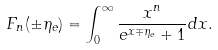Convert formula to latex. <formula><loc_0><loc_0><loc_500><loc_500>F _ { n } ( \pm \eta _ { e } ) = \int _ { 0 } ^ { \infty } \frac { x ^ { n } } { e ^ { x \mp \eta _ { e } } + 1 } d x .</formula> 